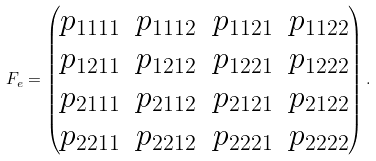<formula> <loc_0><loc_0><loc_500><loc_500>F _ { e } = \begin{pmatrix} p _ { 1 1 1 1 } & p _ { 1 1 1 2 } & p _ { 1 1 2 1 } & p _ { 1 1 2 2 } \\ p _ { 1 2 1 1 } & p _ { 1 2 1 2 } & p _ { 1 2 2 1 } & p _ { 1 2 2 2 } \\ p _ { 2 1 1 1 } & p _ { 2 1 1 2 } & p _ { 2 1 2 1 } & p _ { 2 1 2 2 } \\ p _ { 2 2 1 1 } & p _ { 2 2 1 2 } & p _ { 2 2 2 1 } & p _ { 2 2 2 2 } \\ \end{pmatrix} .</formula> 